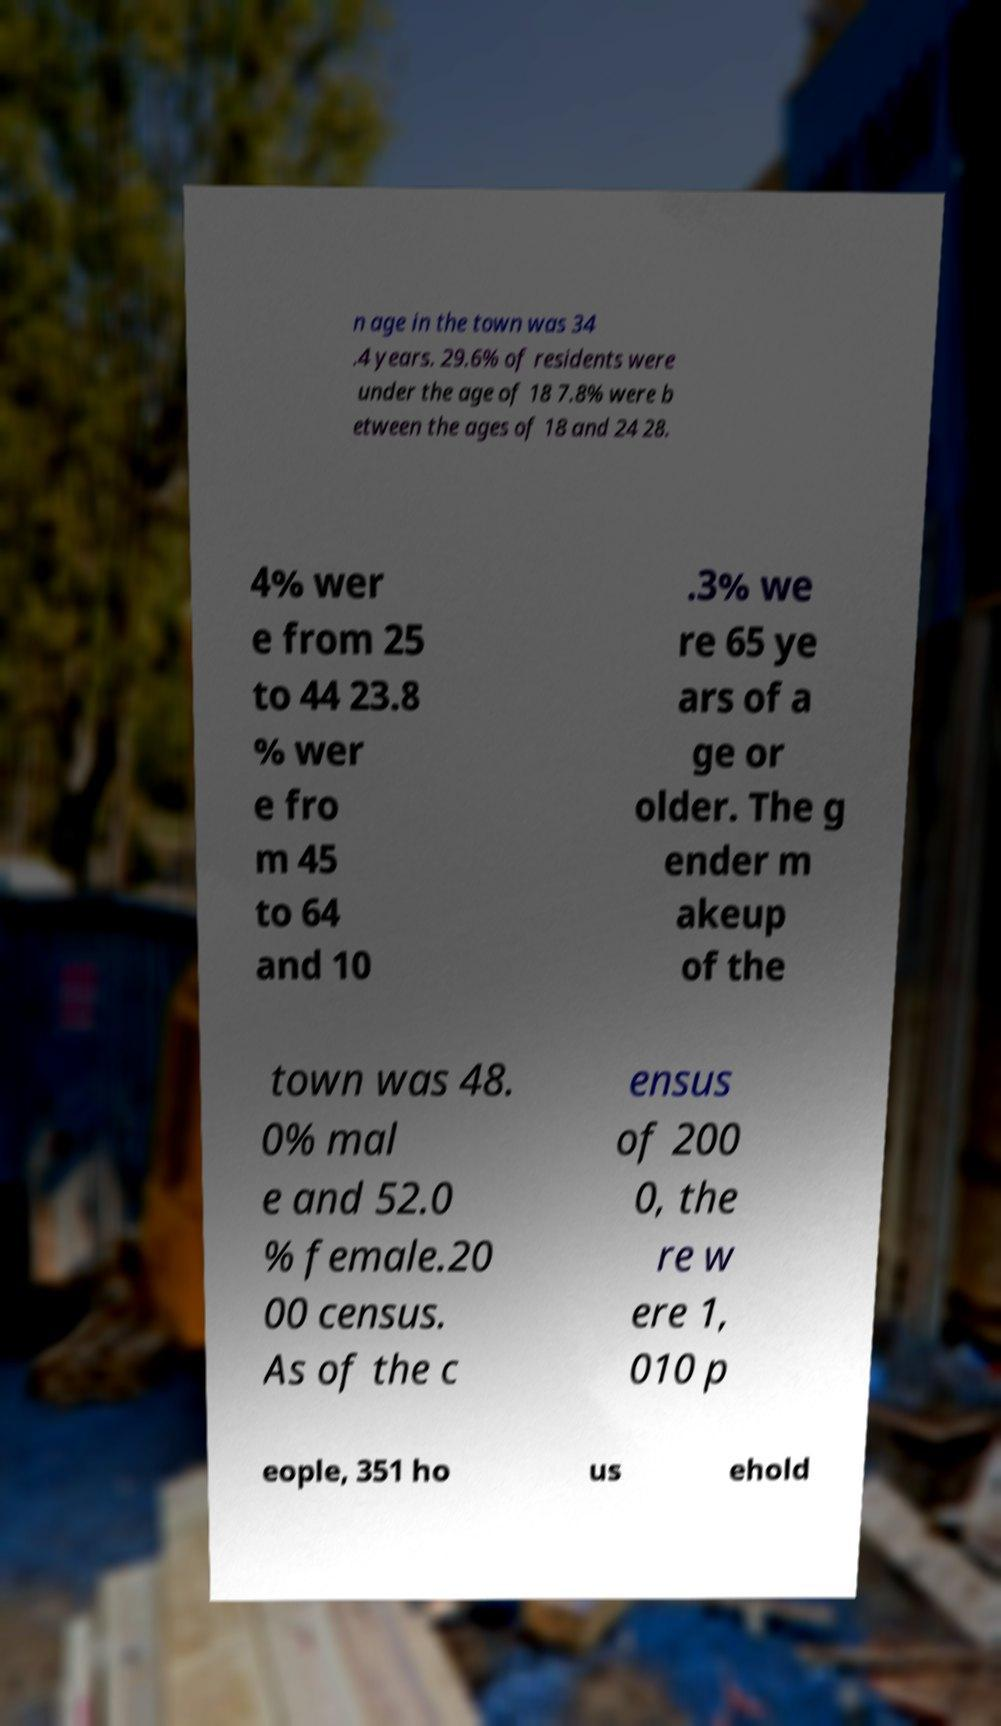Can you accurately transcribe the text from the provided image for me? n age in the town was 34 .4 years. 29.6% of residents were under the age of 18 7.8% were b etween the ages of 18 and 24 28. 4% wer e from 25 to 44 23.8 % wer e fro m 45 to 64 and 10 .3% we re 65 ye ars of a ge or older. The g ender m akeup of the town was 48. 0% mal e and 52.0 % female.20 00 census. As of the c ensus of 200 0, the re w ere 1, 010 p eople, 351 ho us ehold 